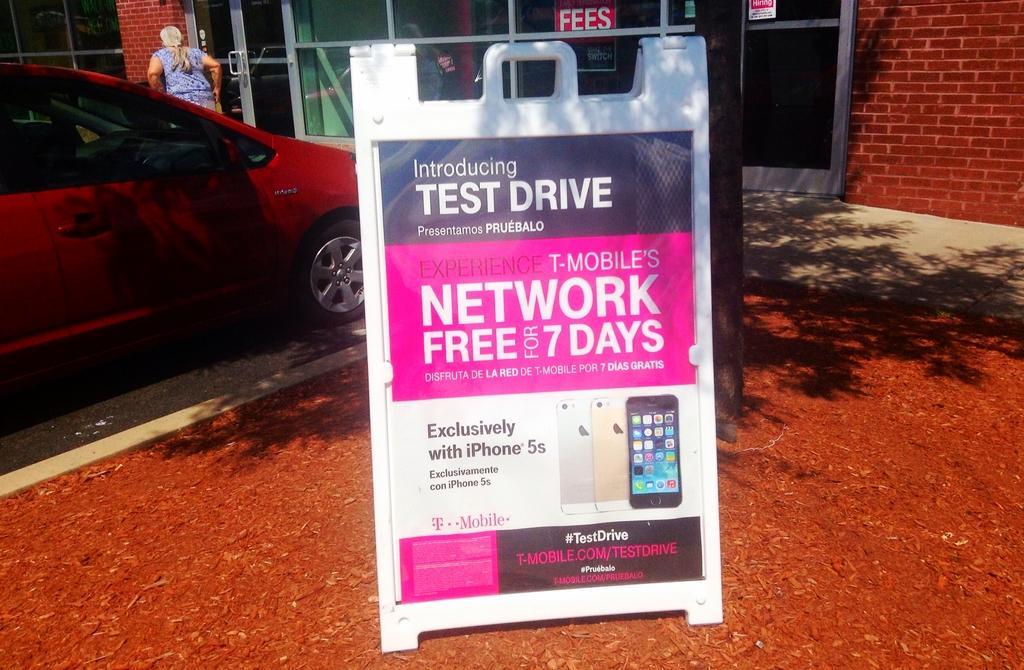How would you summarize this image in a sentence or two? There an advertising board present at the bottom of this image. We can see a car and a woman on the left side of this image and there is a building in the background. 